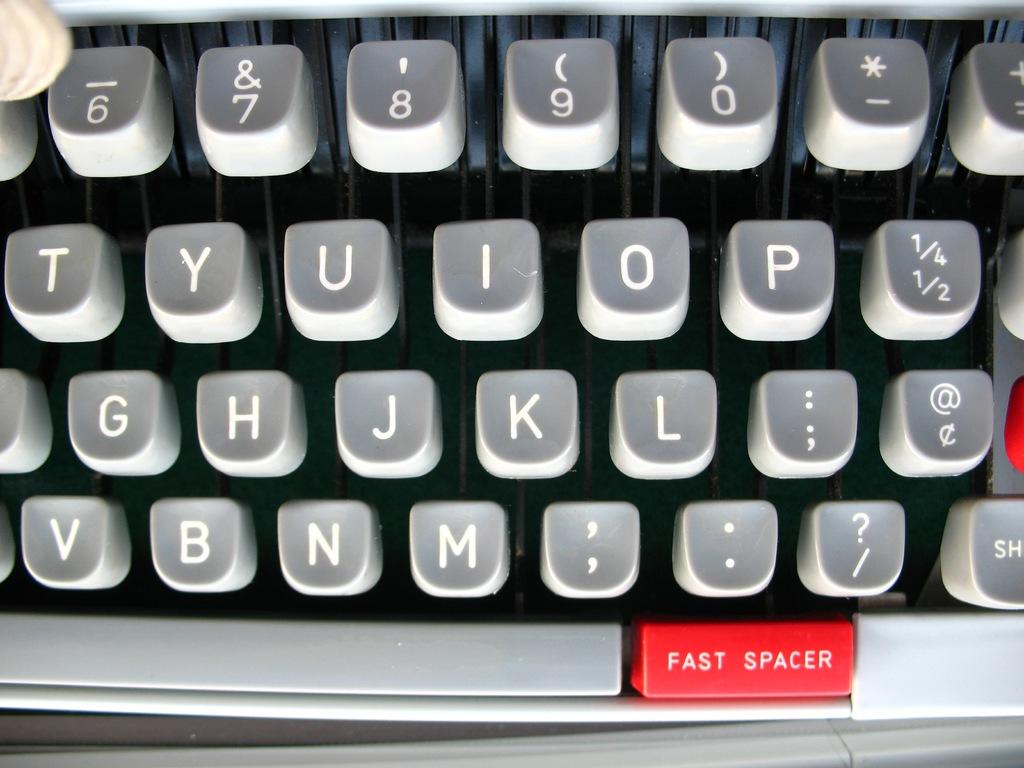Is that a q keyboard?
Provide a short and direct response. Yes. 